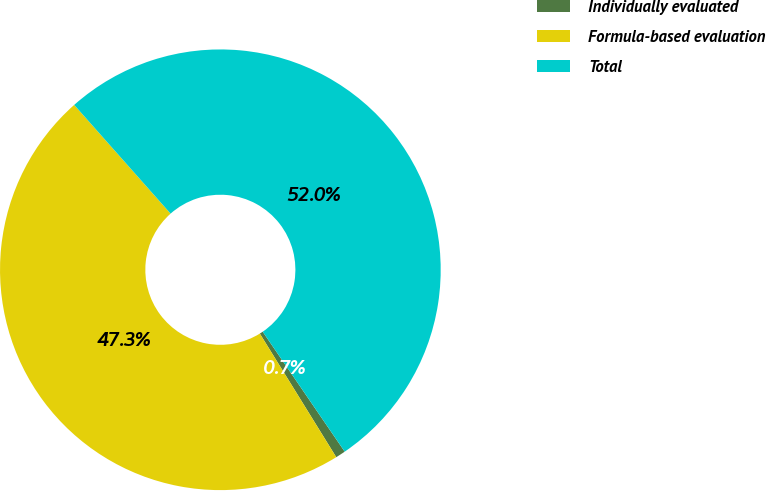<chart> <loc_0><loc_0><loc_500><loc_500><pie_chart><fcel>Individually evaluated<fcel>Formula-based evaluation<fcel>Total<nl><fcel>0.73%<fcel>47.27%<fcel>52.0%<nl></chart> 